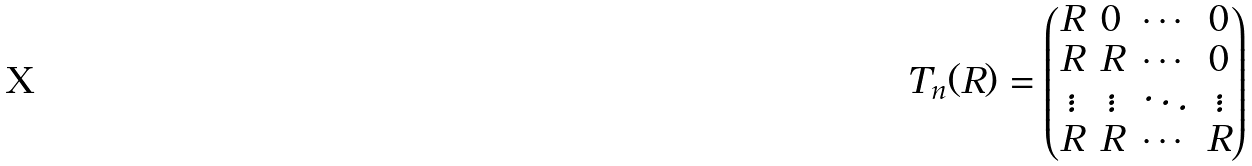Convert formula to latex. <formula><loc_0><loc_0><loc_500><loc_500>T _ { n } ( R ) = \begin{pmatrix} R & 0 & \cdots & 0 \\ R & R & \cdots & 0 \\ \vdots & \vdots & \ddots & \vdots \\ R & R & \cdots & R \\ \end{pmatrix}</formula> 